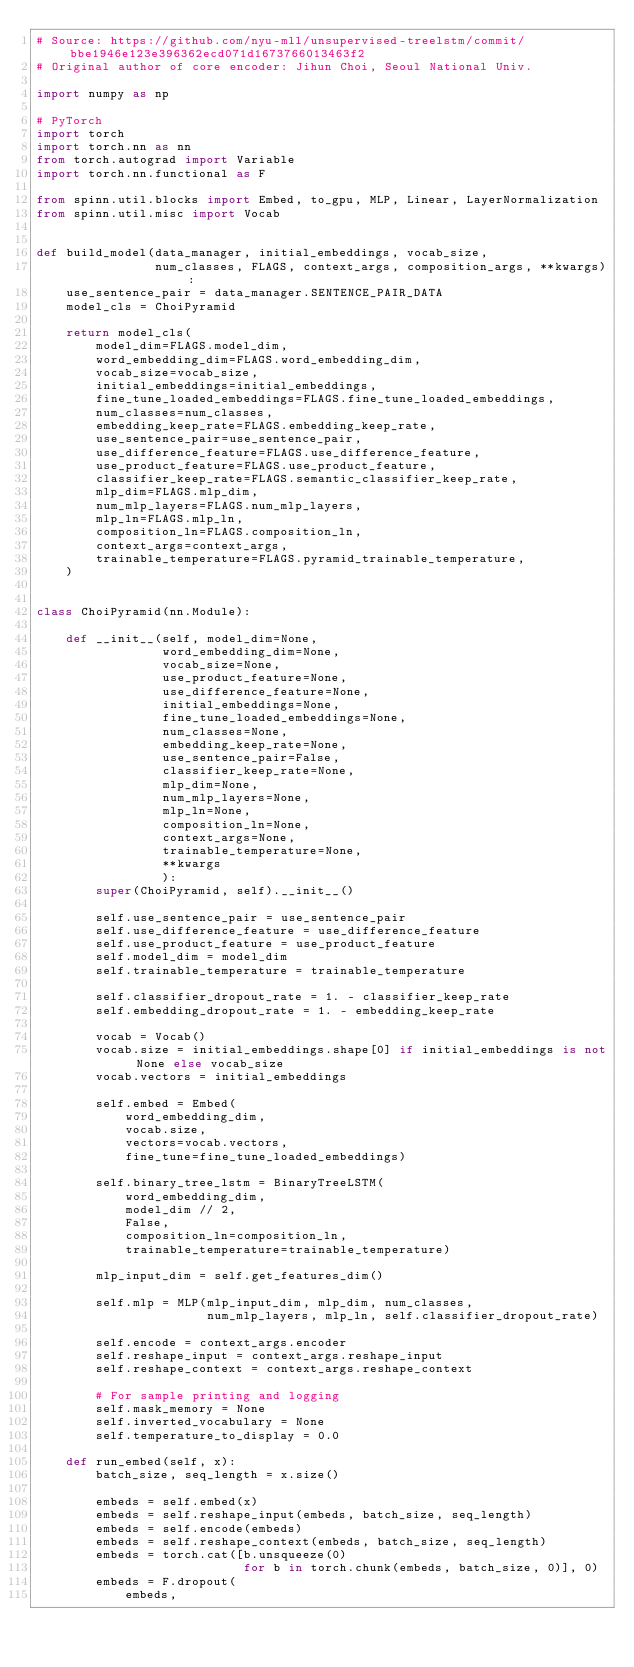<code> <loc_0><loc_0><loc_500><loc_500><_Python_># Source: https://github.com/nyu-mll/unsupervised-treelstm/commit/bbe1946e123e396362ecd071d1673766013463f2
# Original author of core encoder: Jihun Choi, Seoul National Univ.

import numpy as np

# PyTorch
import torch
import torch.nn as nn
from torch.autograd import Variable
import torch.nn.functional as F

from spinn.util.blocks import Embed, to_gpu, MLP, Linear, LayerNormalization
from spinn.util.misc import Vocab


def build_model(data_manager, initial_embeddings, vocab_size,
                num_classes, FLAGS, context_args, composition_args, **kwargs):
    use_sentence_pair = data_manager.SENTENCE_PAIR_DATA
    model_cls = ChoiPyramid

    return model_cls(
        model_dim=FLAGS.model_dim,
        word_embedding_dim=FLAGS.word_embedding_dim,
        vocab_size=vocab_size,
        initial_embeddings=initial_embeddings,
        fine_tune_loaded_embeddings=FLAGS.fine_tune_loaded_embeddings,
        num_classes=num_classes,
        embedding_keep_rate=FLAGS.embedding_keep_rate,
        use_sentence_pair=use_sentence_pair,
        use_difference_feature=FLAGS.use_difference_feature,
        use_product_feature=FLAGS.use_product_feature,
        classifier_keep_rate=FLAGS.semantic_classifier_keep_rate,
        mlp_dim=FLAGS.mlp_dim,
        num_mlp_layers=FLAGS.num_mlp_layers,
        mlp_ln=FLAGS.mlp_ln,
        composition_ln=FLAGS.composition_ln,
        context_args=context_args,
        trainable_temperature=FLAGS.pyramid_trainable_temperature,
    )


class ChoiPyramid(nn.Module):

    def __init__(self, model_dim=None,
                 word_embedding_dim=None,
                 vocab_size=None,
                 use_product_feature=None,
                 use_difference_feature=None,
                 initial_embeddings=None,
                 fine_tune_loaded_embeddings=None,
                 num_classes=None,
                 embedding_keep_rate=None,
                 use_sentence_pair=False,
                 classifier_keep_rate=None,
                 mlp_dim=None,
                 num_mlp_layers=None,
                 mlp_ln=None,
                 composition_ln=None,
                 context_args=None,
                 trainable_temperature=None,
                 **kwargs
                 ):
        super(ChoiPyramid, self).__init__()

        self.use_sentence_pair = use_sentence_pair
        self.use_difference_feature = use_difference_feature
        self.use_product_feature = use_product_feature
        self.model_dim = model_dim
        self.trainable_temperature = trainable_temperature

        self.classifier_dropout_rate = 1. - classifier_keep_rate
        self.embedding_dropout_rate = 1. - embedding_keep_rate

        vocab = Vocab()
        vocab.size = initial_embeddings.shape[0] if initial_embeddings is not None else vocab_size
        vocab.vectors = initial_embeddings

        self.embed = Embed(
            word_embedding_dim,
            vocab.size,
            vectors=vocab.vectors,
            fine_tune=fine_tune_loaded_embeddings)

        self.binary_tree_lstm = BinaryTreeLSTM(
            word_embedding_dim,
            model_dim // 2,
            False,
            composition_ln=composition_ln,
            trainable_temperature=trainable_temperature)

        mlp_input_dim = self.get_features_dim()

        self.mlp = MLP(mlp_input_dim, mlp_dim, num_classes,
                       num_mlp_layers, mlp_ln, self.classifier_dropout_rate)

        self.encode = context_args.encoder
        self.reshape_input = context_args.reshape_input
        self.reshape_context = context_args.reshape_context

        # For sample printing and logging
        self.mask_memory = None
        self.inverted_vocabulary = None
        self.temperature_to_display = 0.0

    def run_embed(self, x):
        batch_size, seq_length = x.size()

        embeds = self.embed(x)
        embeds = self.reshape_input(embeds, batch_size, seq_length)
        embeds = self.encode(embeds)
        embeds = self.reshape_context(embeds, batch_size, seq_length)
        embeds = torch.cat([b.unsqueeze(0)
                            for b in torch.chunk(embeds, batch_size, 0)], 0)
        embeds = F.dropout(
            embeds,</code> 